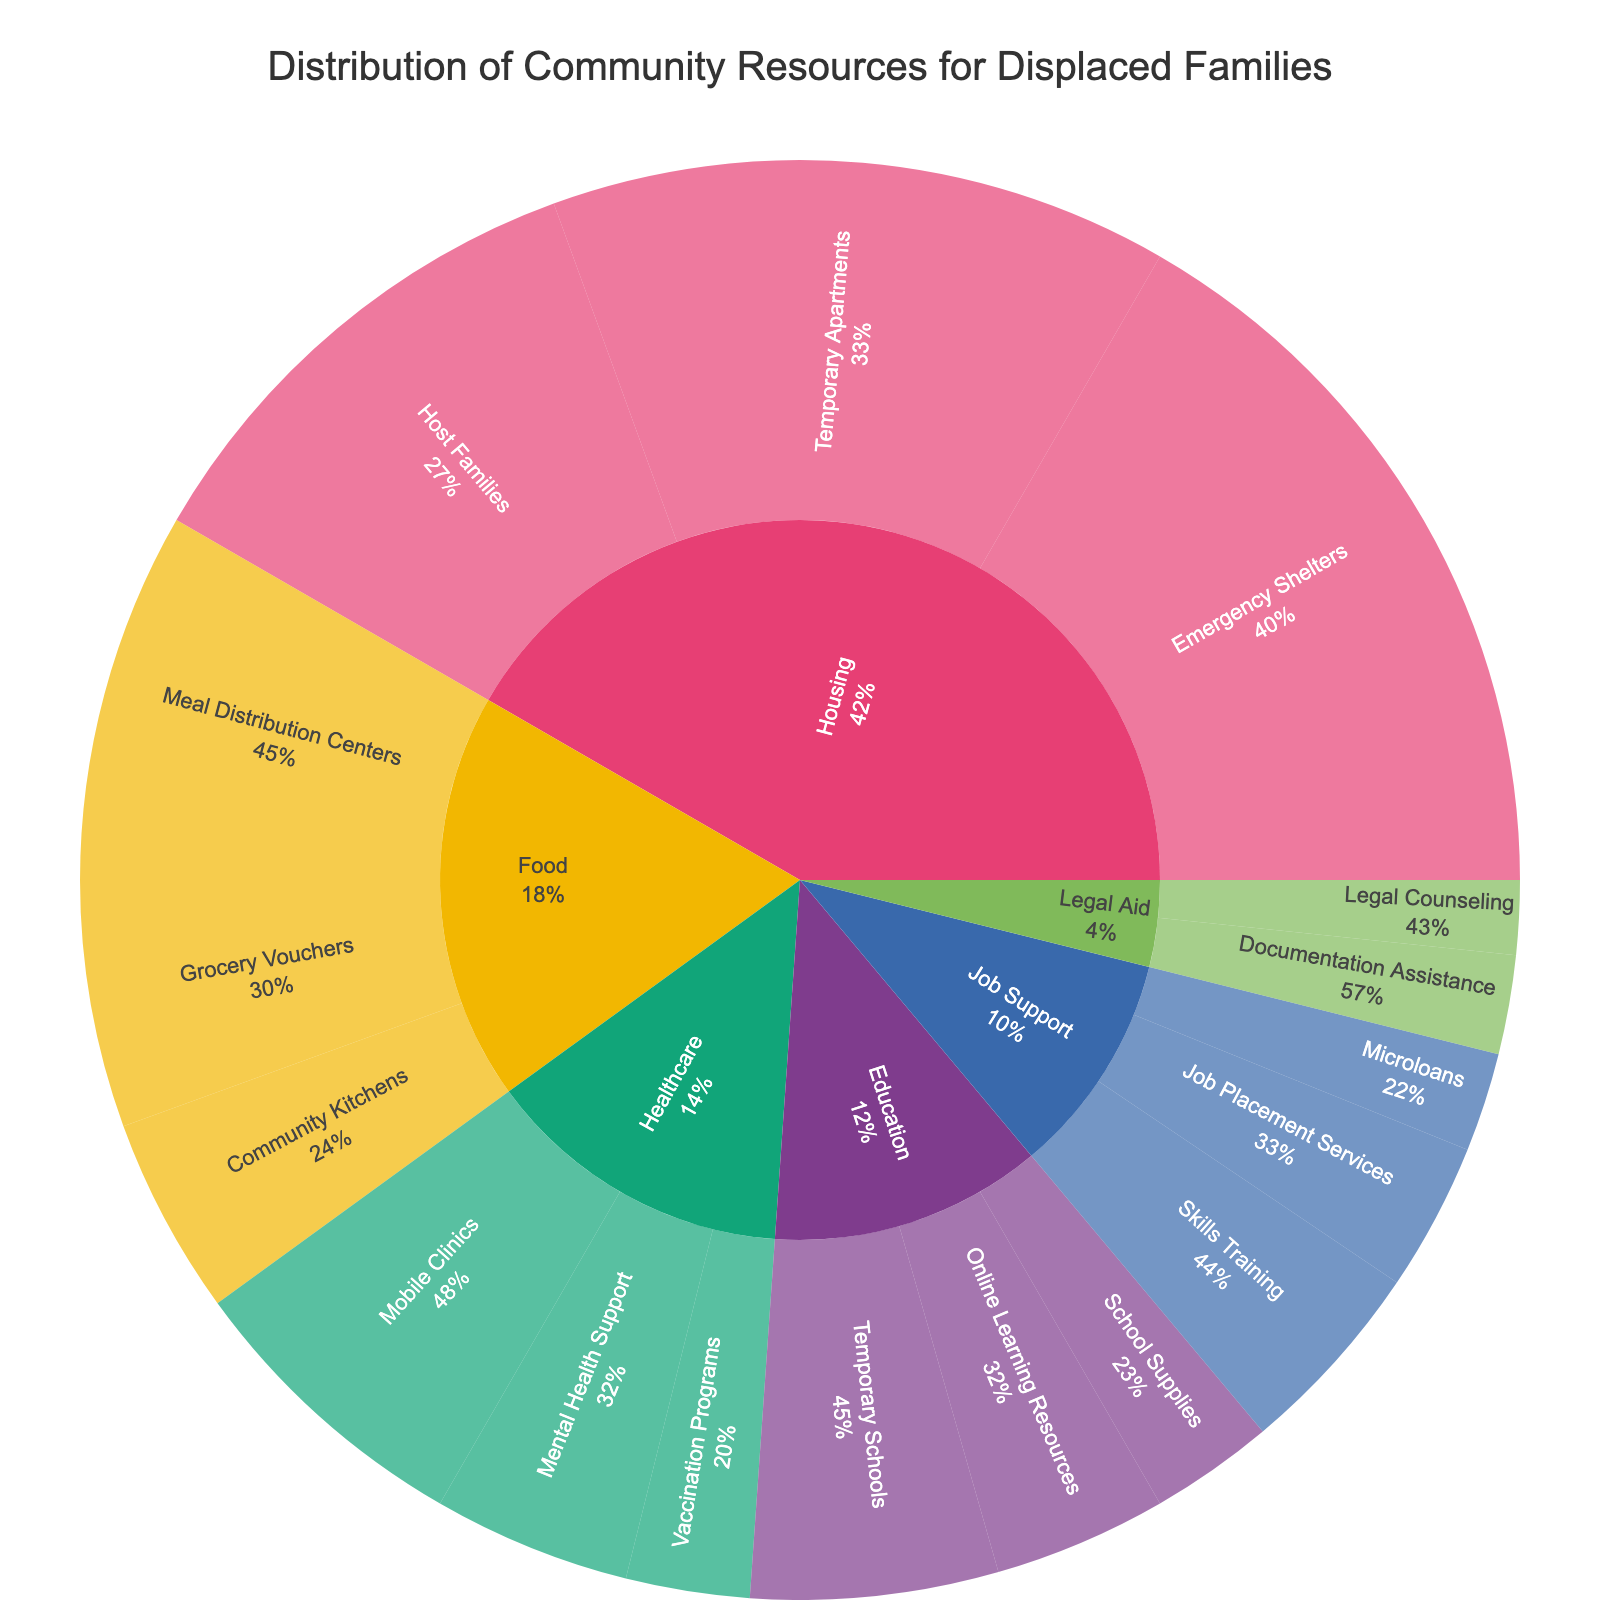What is the total value allocated to the Housing category? The total value for the Housing category can be found by adding the values of its subcategories: Emergency Shelters (30), Temporary Apartments (25), and Host Families (20). So, 30 + 25 + 20 = 75.
Answer: 75 Which subcategory in the Healthcare category has the lowest value? By examining the values for the subcategories in Healthcare, you'll see: Mobile Clinics (12), Mental Health Support (8), and Vaccination Programs (5). The lowest is Vaccination Programs with a value of 5.
Answer: Vaccination Programs How does the value of Temporary Schools in Education compare to Documentation Assistance in Legal Aid? Temporary Schools in Education have a value of 10 and Documentation Assistance in Legal Aid has a value of 4. The value for Temporary Schools is greater.
Answer: Temporary Schools has a higher value What percentage of the total value for the Food category is allocated to Meal Distribution Centers? Meal Distribution Centers has a value of 15. The total value for Food is the sum of all subcategories: 15 (Meal Distribution Centers) + 10 (Grocery Vouchers) + 8 (Community Kitchens) = 33. The percentage is calculated as 15/33 * 100 ≈ 45.5%.
Answer: 45.5% Which category receives the most resources overall? The resources allocated to each category sum up as follows: Housing (75), Food (33), Healthcare (25), Education (22), Job Support (18), Legal Aid (7). Housing has the highest total value with 75.
Answer: Housing What is the difference between the highest and lowest allocated subcategory within Housing? Within Housing, the subcategories and their values are: Emergency Shelters (30), Temporary Apartments (25), and Host Families (20). The difference between the highest (Emergency Shelters) and lowest (Host Families) is 30 - 20 = 10.
Answer: 10 What fraction of the total resources is allocated to Job Support? First, calculate the total resources: Housing (75) + Food (33) + Healthcare (25) + Education (22) + Job Support (18) + Legal Aid (7) = 180. The fraction allocated to Job Support is 18/180, which simplifies to 1/10.
Answer: 1/10 How many subcategories have a value greater than 20? The subcategories with values greater than 20 are Emergency Shelters (30), Temporary Apartments (25), and Host Families (20). Only two values are strictly greater than 20: Emergency Shelters and Temporary Apartments.
Answer: 2 Which category has the most subcategories and what are they? By counting the subcategories for each category: Housing has 3, Food has 3, Healthcare has 3, Education has 3, Job Support has 3, and Legal Aid has 2. So, Housing ties with Food, Healthcare, Education, and Job Support for having the most subcategories, each with 3.
Answer: Housing, Food, Healthcare, Education, Job Support with 3 subcategories each 